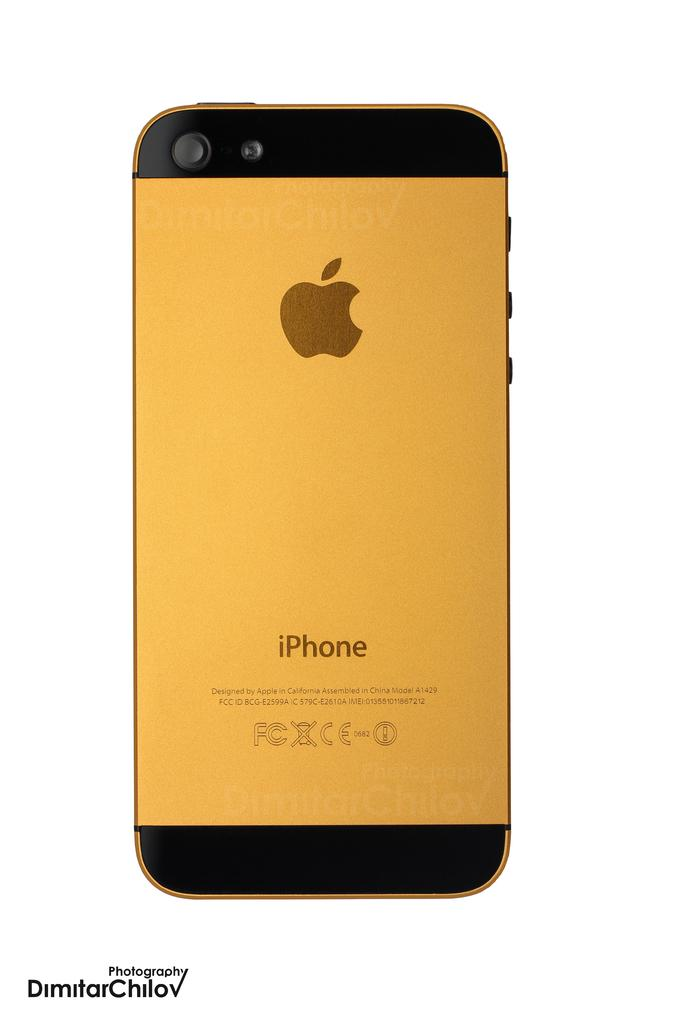Provide a one-sentence caption for the provided image. The back of a gold iPhone which says it was designed by Apple in California and assembled in China. 